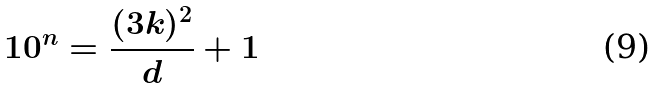Convert formula to latex. <formula><loc_0><loc_0><loc_500><loc_500>1 0 ^ { n } = \frac { ( 3 k ) ^ { 2 } } { d } + 1</formula> 